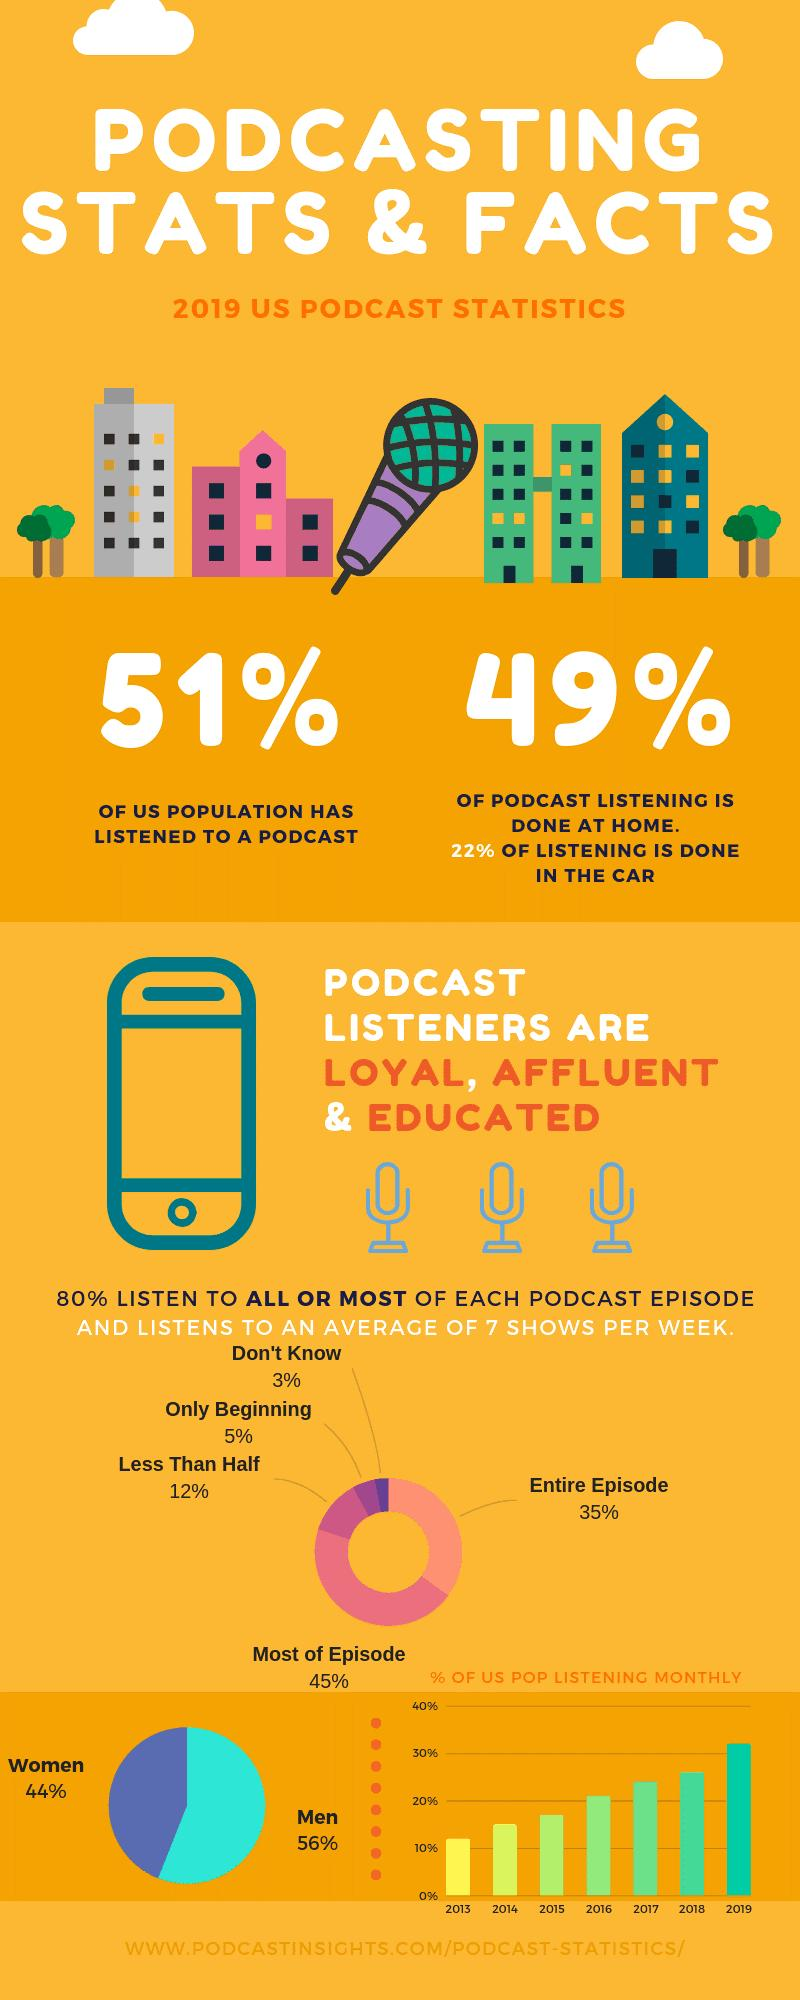Point out several critical features in this image. According to recent statistics, women have a higher share in listening to podcasts compared to men. According to a recent survey, the majority of podcast listening, 51%, occurs outside of the home. According to a recent survey, approximately 49% of the US population has not listened to a podcast. Out of all the episodes, the one with the highest share of the entire episode is the one that has the majority of the episode. 